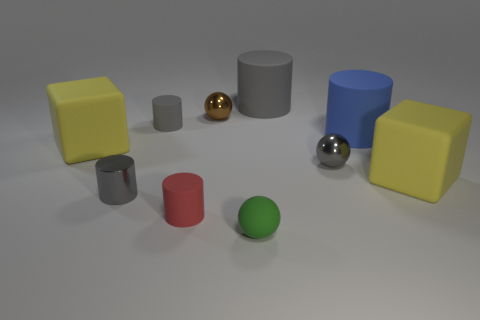What is the gray object that is both behind the gray metal ball and to the right of the brown metal sphere made of?
Give a very brief answer. Rubber. There is a small green matte object; does it have the same shape as the gray matte thing that is on the right side of the green sphere?
Give a very brief answer. No. What material is the small gray object in front of the gray metallic object that is behind the large yellow rubber block that is right of the red cylinder made of?
Keep it short and to the point. Metal. How many other objects are there of the same size as the brown shiny object?
Ensure brevity in your answer.  5. Does the tiny metallic cylinder have the same color as the rubber ball?
Keep it short and to the point. No. There is a big yellow object that is in front of the small ball that is to the right of the tiny green rubber object; what number of small objects are behind it?
Your answer should be compact. 3. What is the large gray cylinder behind the gray metallic object on the right side of the matte ball made of?
Keep it short and to the point. Rubber. Is there a tiny blue object of the same shape as the green object?
Ensure brevity in your answer.  No. What is the color of the cylinder that is the same size as the blue matte object?
Offer a very short reply. Gray. What number of things are gray things that are on the left side of the red object or tiny cylinders behind the big blue cylinder?
Make the answer very short. 2. 